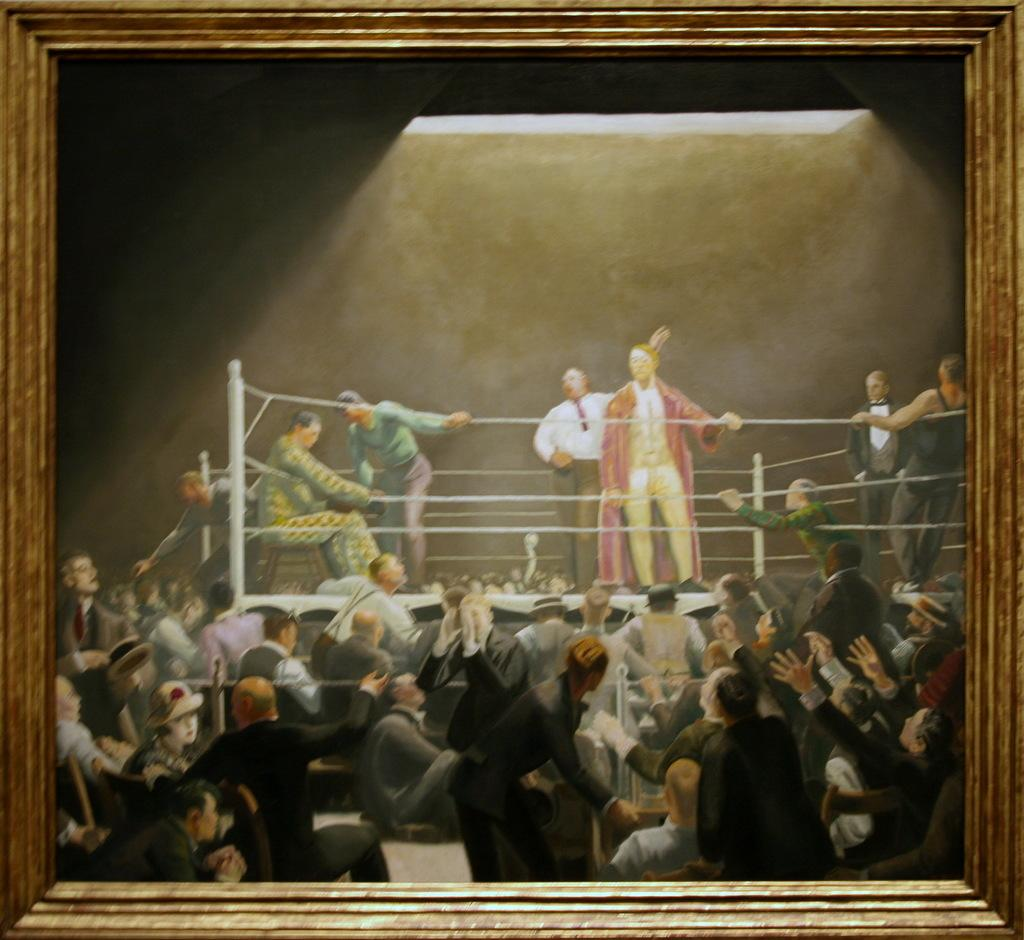What type of artwork is depicted in the image? The image is a painting. What object can be seen in the painting? There is a photo frame in the painting. What activity is taking place in the painting? There is a boxing court in the painting, suggesting that people are boxing. Are there any people present in the painting? Yes, there are people in the painting. What can be seen at the top of the painting? There is light visible at the top of the painting. What type of gold can be seen on the floor of the boxing court in the painting? There is no gold visible on the floor of the boxing court in the painting. How much salt is present on the people in the painting? There is no salt present on the people in the painting. 